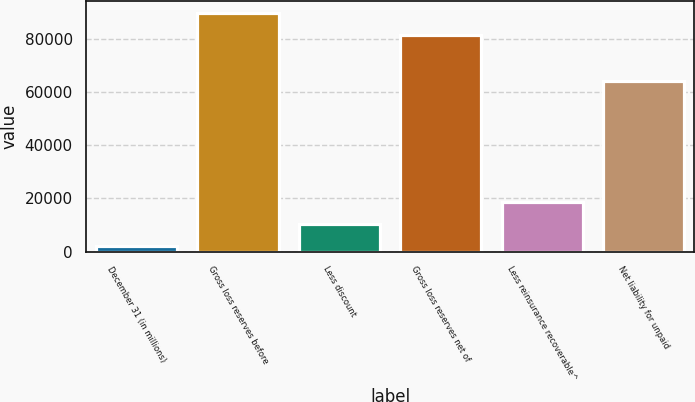Convert chart. <chart><loc_0><loc_0><loc_500><loc_500><bar_chart><fcel>December 31 (in millions)<fcel>Gross loss reserves before<fcel>Less discount<fcel>Gross loss reserves net of<fcel>Less reinsurance recoverable^<fcel>Net liability for unpaid<nl><fcel>2013<fcel>89855.9<fcel>10321.9<fcel>81547<fcel>18630.8<fcel>64316<nl></chart> 